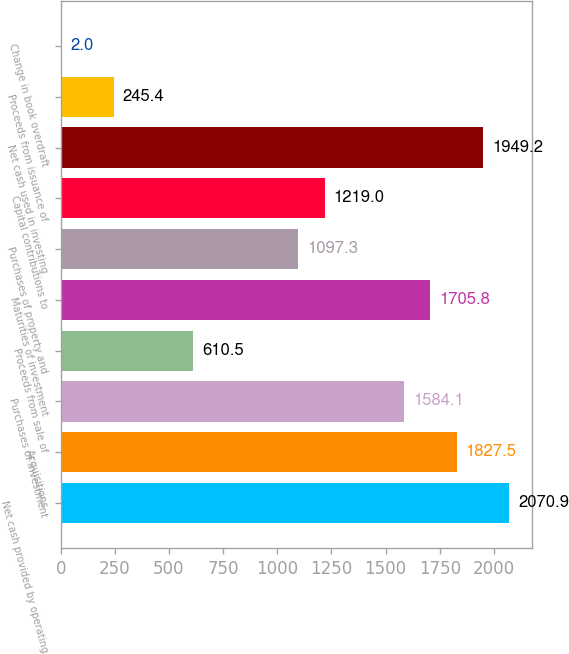Convert chart to OTSL. <chart><loc_0><loc_0><loc_500><loc_500><bar_chart><fcel>Net cash provided by operating<fcel>Acquisitions<fcel>Purchases of investment<fcel>Proceeds from sale of<fcel>Maturities of investment<fcel>Purchases of property and<fcel>Capital contributions to<fcel>Net cash used in investing<fcel>Proceeds from issuance of<fcel>Change in book overdraft<nl><fcel>2070.9<fcel>1827.5<fcel>1584.1<fcel>610.5<fcel>1705.8<fcel>1097.3<fcel>1219<fcel>1949.2<fcel>245.4<fcel>2<nl></chart> 